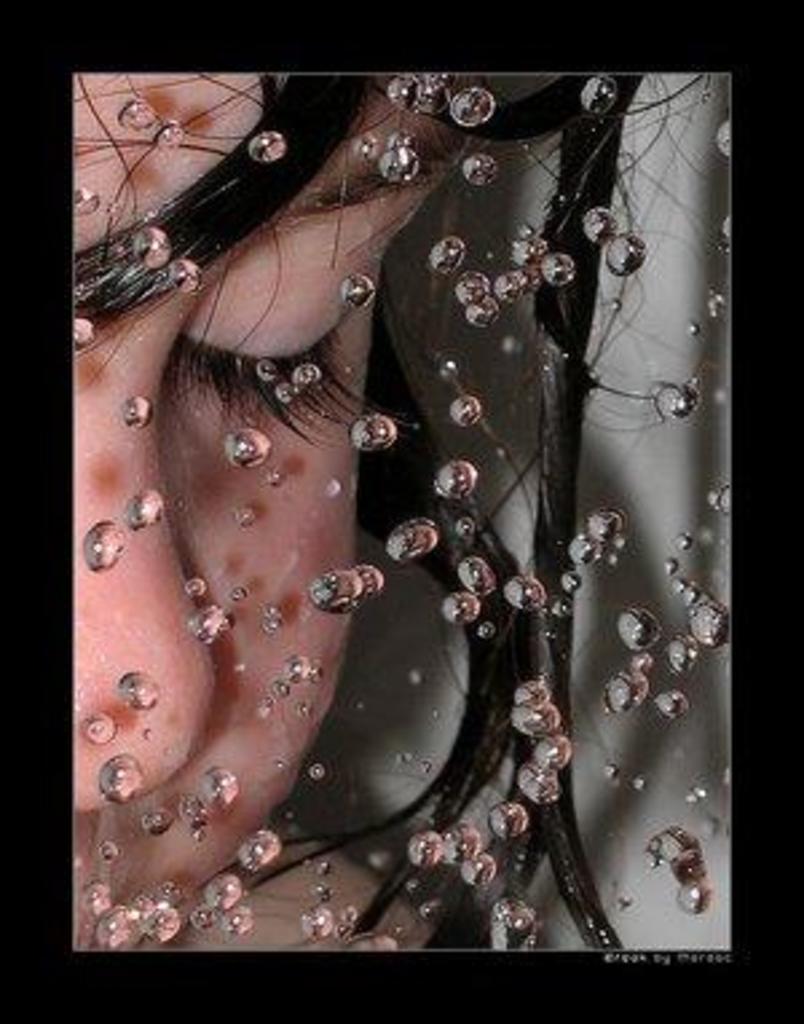Could you give a brief overview of what you see in this image? In the image there is a person closing eyes, in the front there are many water bubbles. 